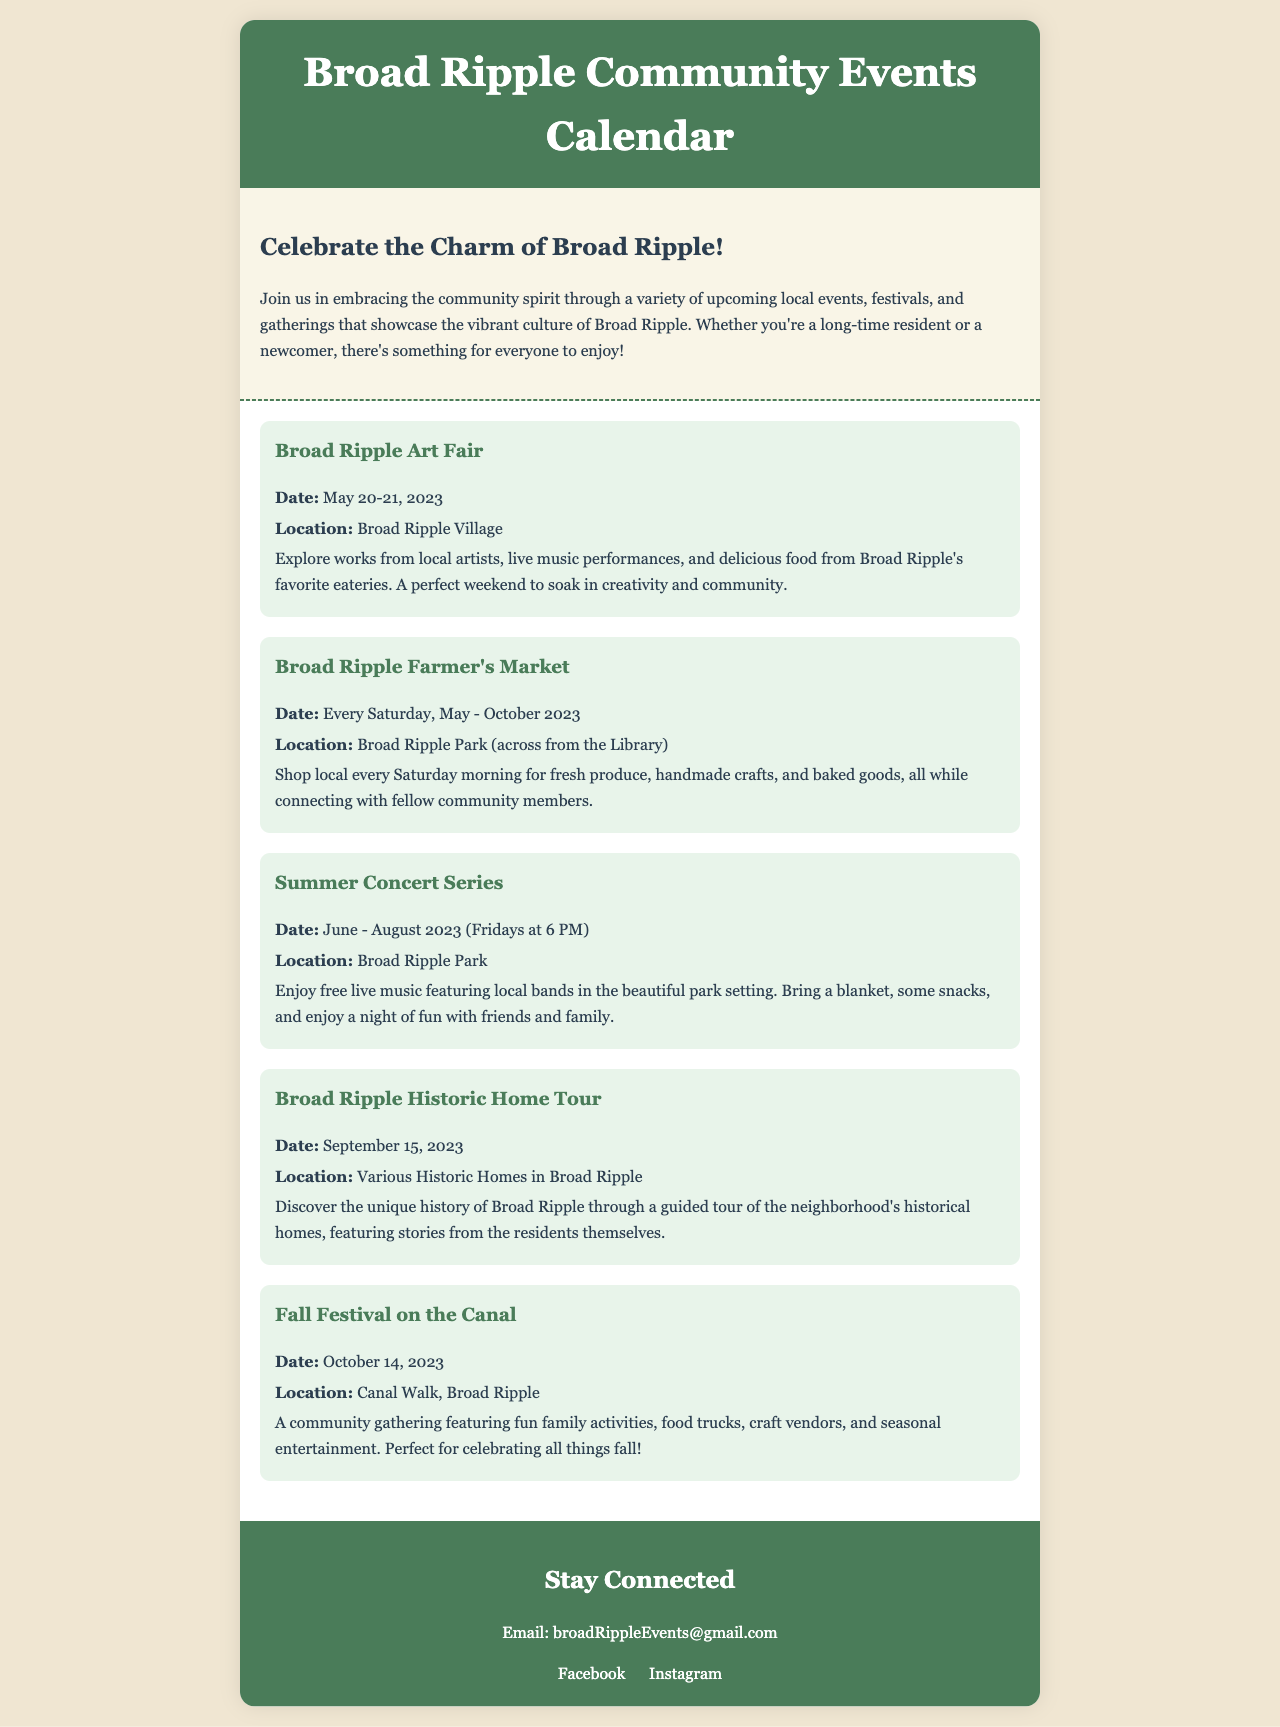What event takes place on May 20-21, 2023? The event that takes place on these dates is the Broad Ripple Art Fair.
Answer: Broad Ripple Art Fair When does the Broad Ripple Farmer's Market occur? The Broad Ripple Farmer's Market takes place every Saturday from May to October 2023.
Answer: Every Saturday, May - October 2023 What type of event is the Summer Concert Series? The Summer Concert Series features free live music with local bands.
Answer: Free live music Where is the Fall Festival on the Canal held? The Fall Festival on the Canal is located along the Canal Walk in Broad Ripple.
Answer: Canal Walk, Broad Ripple What is the date of the Broad Ripple Historic Home Tour? The Broad Ripple Historic Home Tour occurs on September 15, 2023.
Answer: September 15, 2023 What season does the Summer Concert Series take place in? The Summer Concert Series takes place during the summer months.
Answer: Summer How often does the Broad Ripple Farmer's Market occur? The Broad Ripple Farmer's Market occurs weekly, every Saturday.
Answer: Weekly What is the main purpose of the events listed in the calendar? The events celebrate the charm and culture of Broad Ripple.
Answer: Celebrate the charm and culture 